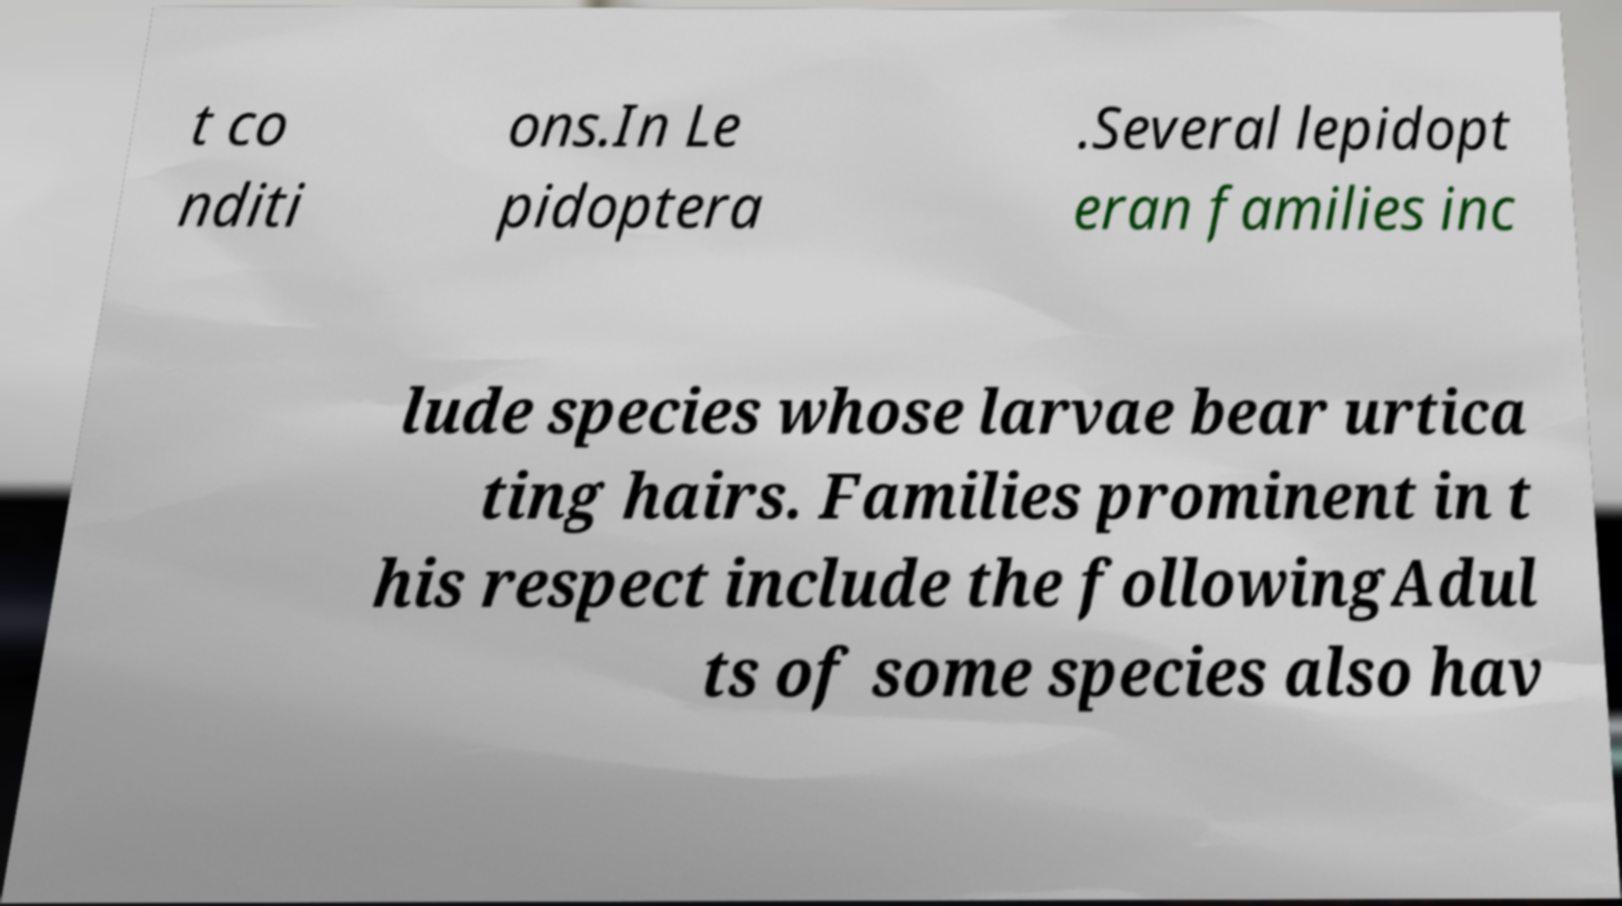Could you assist in decoding the text presented in this image and type it out clearly? t co nditi ons.In Le pidoptera .Several lepidopt eran families inc lude species whose larvae bear urtica ting hairs. Families prominent in t his respect include the followingAdul ts of some species also hav 